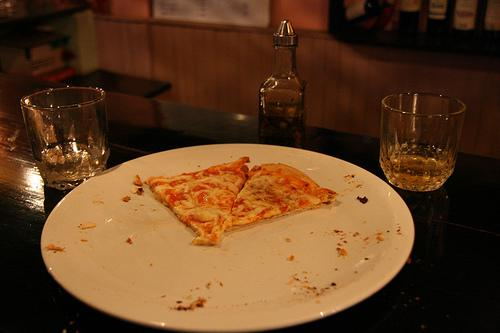Question: what is on the plate?
Choices:
A. Spaghetti.
B. French fries.
C. Vegetables.
D. Pizza.
Answer with the letter. Answer: D Question: how many slices?
Choices:
A. Three.
B. Two.
C. Four.
D. One.
Answer with the letter. Answer: B Question: why was two slices left?
Choices:
A. Everyone was full.
B. No indication.
C. To give away.
D. To save for later.
Answer with the letter. Answer: B Question: what type of pizza?
Choices:
A. Pepperoni.
B. Cheese.
C. Sausage.
D. Veggie.
Answer with the letter. Answer: B Question: what is in the glasses?
Choices:
A. Not identifiable.
B. Champagne.
C. Juice.
D. Milk.
Answer with the letter. Answer: A 